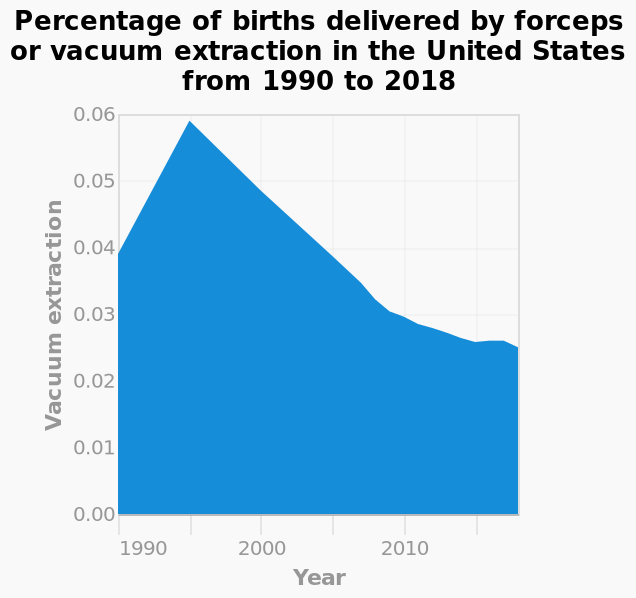<image>
What year had the highest percentage of forcep/vacuum suction assisted births? 1995 What does the y-axis represent in the area diagram?  The y-axis represents the percentage of births delivered by vacuum extraction. 